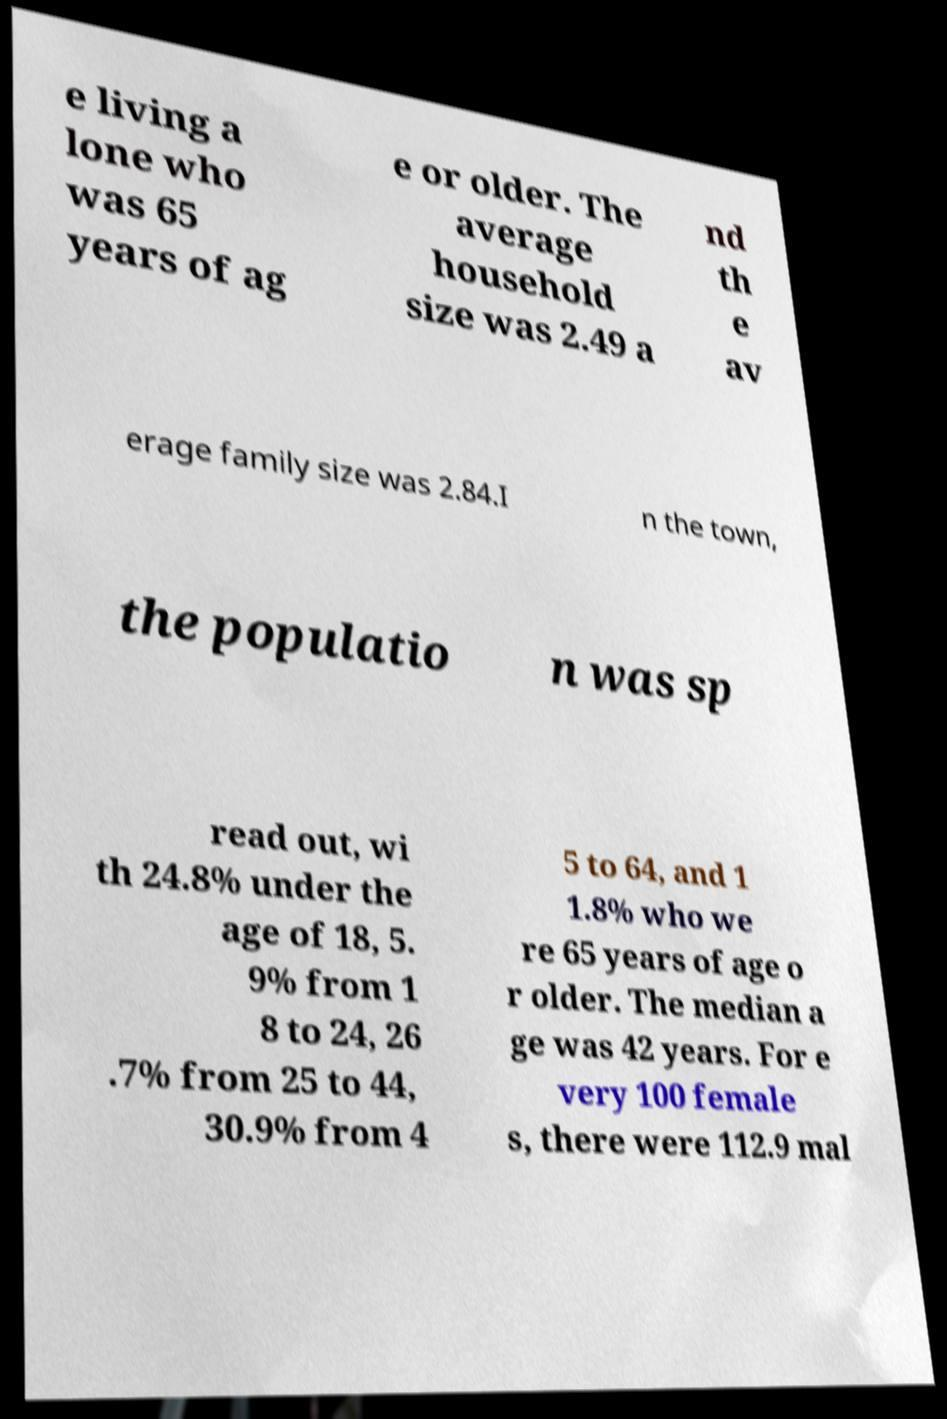For documentation purposes, I need the text within this image transcribed. Could you provide that? e living a lone who was 65 years of ag e or older. The average household size was 2.49 a nd th e av erage family size was 2.84.I n the town, the populatio n was sp read out, wi th 24.8% under the age of 18, 5. 9% from 1 8 to 24, 26 .7% from 25 to 44, 30.9% from 4 5 to 64, and 1 1.8% who we re 65 years of age o r older. The median a ge was 42 years. For e very 100 female s, there were 112.9 mal 